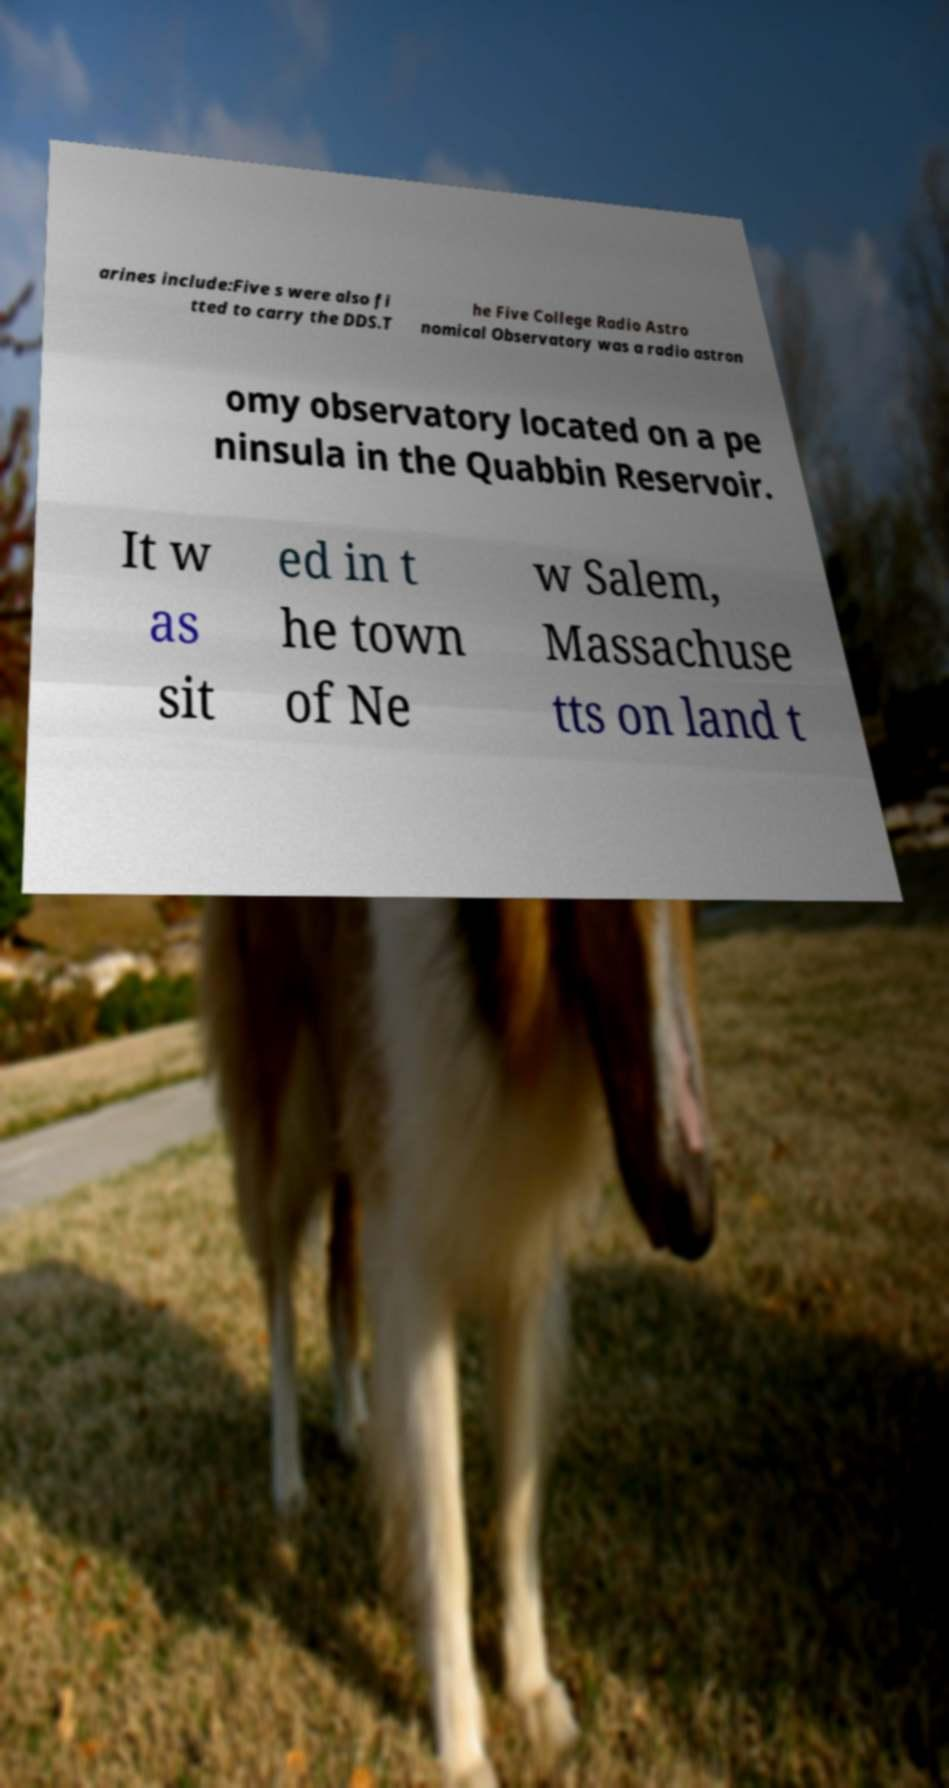I need the written content from this picture converted into text. Can you do that? arines include:Five s were also fi tted to carry the DDS.T he Five College Radio Astro nomical Observatory was a radio astron omy observatory located on a pe ninsula in the Quabbin Reservoir. It w as sit ed in t he town of Ne w Salem, Massachuse tts on land t 